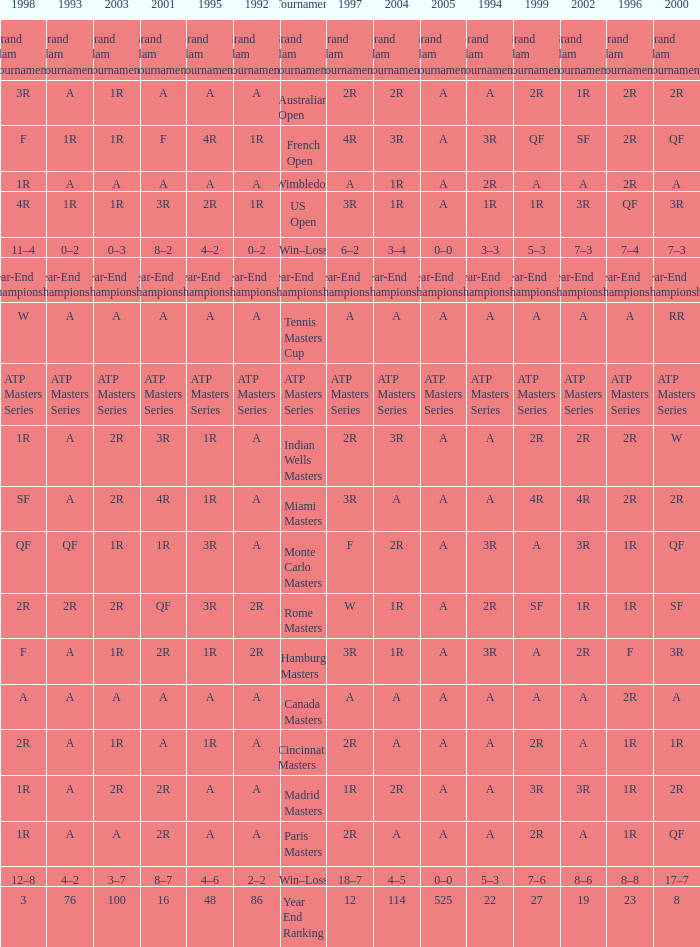What is Tournament, when 2000 is "A"? Wimbledon, Canada Masters. 